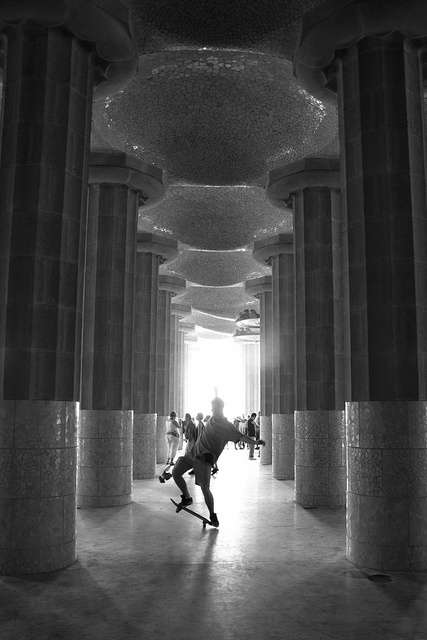Describe the objects in this image and their specific colors. I can see people in black, gray, darkgray, and lightgray tones, people in black, darkgray, gray, and lightgray tones, people in black, gray, darkgray, and lightgray tones, skateboard in black, darkgray, gray, and lightgray tones, and people in black, gray, darkgray, and lightgray tones in this image. 